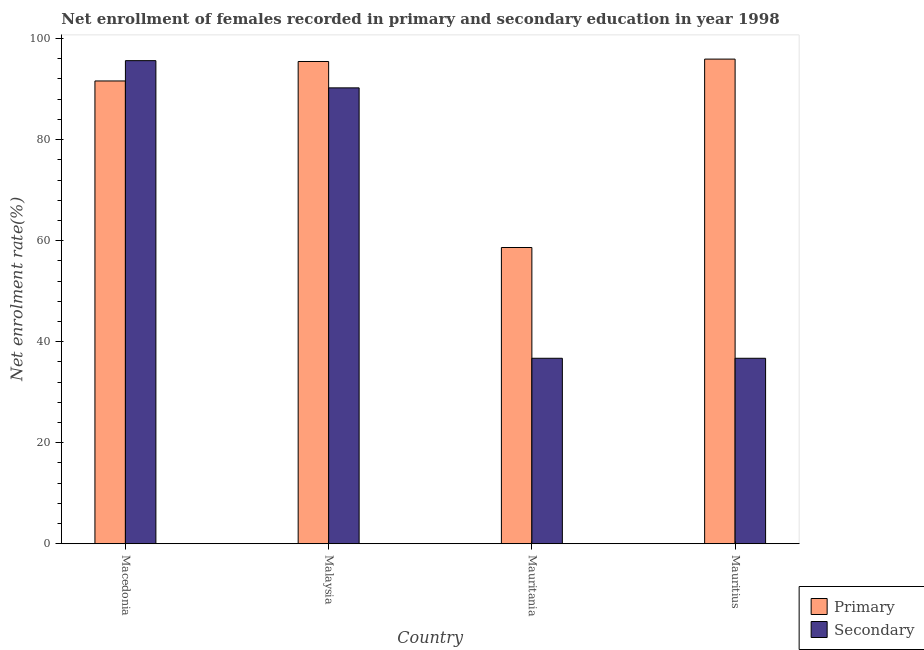Are the number of bars on each tick of the X-axis equal?
Make the answer very short. Yes. How many bars are there on the 3rd tick from the left?
Offer a terse response. 2. What is the label of the 3rd group of bars from the left?
Make the answer very short. Mauritania. In how many cases, is the number of bars for a given country not equal to the number of legend labels?
Ensure brevity in your answer.  0. What is the enrollment rate in secondary education in Malaysia?
Your answer should be very brief. 90.24. Across all countries, what is the maximum enrollment rate in secondary education?
Offer a terse response. 95.63. Across all countries, what is the minimum enrollment rate in primary education?
Offer a very short reply. 58.64. In which country was the enrollment rate in secondary education maximum?
Make the answer very short. Macedonia. In which country was the enrollment rate in secondary education minimum?
Your response must be concise. Mauritania. What is the total enrollment rate in primary education in the graph?
Provide a short and direct response. 341.64. What is the difference between the enrollment rate in primary education in Malaysia and that in Mauritania?
Give a very brief answer. 36.82. What is the difference between the enrollment rate in primary education in Mauritania and the enrollment rate in secondary education in Macedonia?
Make the answer very short. -36.99. What is the average enrollment rate in primary education per country?
Offer a terse response. 85.41. What is the difference between the enrollment rate in secondary education and enrollment rate in primary education in Mauritania?
Make the answer very short. -21.93. What is the ratio of the enrollment rate in secondary education in Macedonia to that in Mauritania?
Offer a very short reply. 2.6. Is the enrollment rate in primary education in Malaysia less than that in Mauritania?
Make the answer very short. No. Is the difference between the enrollment rate in secondary education in Malaysia and Mauritius greater than the difference between the enrollment rate in primary education in Malaysia and Mauritius?
Your answer should be compact. Yes. What is the difference between the highest and the second highest enrollment rate in primary education?
Keep it short and to the point. 0.47. What is the difference between the highest and the lowest enrollment rate in primary education?
Provide a short and direct response. 37.29. Is the sum of the enrollment rate in secondary education in Mauritania and Mauritius greater than the maximum enrollment rate in primary education across all countries?
Offer a terse response. No. What does the 1st bar from the left in Mauritius represents?
Keep it short and to the point. Primary. What does the 1st bar from the right in Malaysia represents?
Provide a short and direct response. Secondary. How many countries are there in the graph?
Ensure brevity in your answer.  4. Are the values on the major ticks of Y-axis written in scientific E-notation?
Your response must be concise. No. How many legend labels are there?
Provide a succinct answer. 2. How are the legend labels stacked?
Ensure brevity in your answer.  Vertical. What is the title of the graph?
Offer a very short reply. Net enrollment of females recorded in primary and secondary education in year 1998. Does "Merchandise exports" appear as one of the legend labels in the graph?
Give a very brief answer. No. What is the label or title of the X-axis?
Your answer should be compact. Country. What is the label or title of the Y-axis?
Your answer should be compact. Net enrolment rate(%). What is the Net enrolment rate(%) in Primary in Macedonia?
Your answer should be compact. 91.61. What is the Net enrolment rate(%) of Secondary in Macedonia?
Offer a very short reply. 95.63. What is the Net enrolment rate(%) in Primary in Malaysia?
Your response must be concise. 95.46. What is the Net enrolment rate(%) in Secondary in Malaysia?
Your answer should be compact. 90.24. What is the Net enrolment rate(%) in Primary in Mauritania?
Your answer should be very brief. 58.64. What is the Net enrolment rate(%) in Secondary in Mauritania?
Provide a succinct answer. 36.71. What is the Net enrolment rate(%) of Primary in Mauritius?
Make the answer very short. 95.93. What is the Net enrolment rate(%) in Secondary in Mauritius?
Keep it short and to the point. 36.71. Across all countries, what is the maximum Net enrolment rate(%) of Primary?
Provide a succinct answer. 95.93. Across all countries, what is the maximum Net enrolment rate(%) of Secondary?
Provide a short and direct response. 95.63. Across all countries, what is the minimum Net enrolment rate(%) of Primary?
Your response must be concise. 58.64. Across all countries, what is the minimum Net enrolment rate(%) of Secondary?
Provide a short and direct response. 36.71. What is the total Net enrolment rate(%) in Primary in the graph?
Offer a terse response. 341.64. What is the total Net enrolment rate(%) of Secondary in the graph?
Provide a short and direct response. 259.29. What is the difference between the Net enrolment rate(%) in Primary in Macedonia and that in Malaysia?
Offer a terse response. -3.85. What is the difference between the Net enrolment rate(%) of Secondary in Macedonia and that in Malaysia?
Provide a short and direct response. 5.39. What is the difference between the Net enrolment rate(%) of Primary in Macedonia and that in Mauritania?
Provide a succinct answer. 32.97. What is the difference between the Net enrolment rate(%) in Secondary in Macedonia and that in Mauritania?
Offer a terse response. 58.91. What is the difference between the Net enrolment rate(%) of Primary in Macedonia and that in Mauritius?
Give a very brief answer. -4.32. What is the difference between the Net enrolment rate(%) in Secondary in Macedonia and that in Mauritius?
Give a very brief answer. 58.91. What is the difference between the Net enrolment rate(%) in Primary in Malaysia and that in Mauritania?
Offer a terse response. 36.82. What is the difference between the Net enrolment rate(%) of Secondary in Malaysia and that in Mauritania?
Provide a succinct answer. 53.53. What is the difference between the Net enrolment rate(%) in Primary in Malaysia and that in Mauritius?
Give a very brief answer. -0.47. What is the difference between the Net enrolment rate(%) in Secondary in Malaysia and that in Mauritius?
Make the answer very short. 53.53. What is the difference between the Net enrolment rate(%) in Primary in Mauritania and that in Mauritius?
Your answer should be very brief. -37.29. What is the difference between the Net enrolment rate(%) in Secondary in Mauritania and that in Mauritius?
Provide a succinct answer. -0. What is the difference between the Net enrolment rate(%) in Primary in Macedonia and the Net enrolment rate(%) in Secondary in Malaysia?
Provide a short and direct response. 1.37. What is the difference between the Net enrolment rate(%) in Primary in Macedonia and the Net enrolment rate(%) in Secondary in Mauritania?
Offer a terse response. 54.9. What is the difference between the Net enrolment rate(%) in Primary in Macedonia and the Net enrolment rate(%) in Secondary in Mauritius?
Keep it short and to the point. 54.89. What is the difference between the Net enrolment rate(%) of Primary in Malaysia and the Net enrolment rate(%) of Secondary in Mauritania?
Ensure brevity in your answer.  58.75. What is the difference between the Net enrolment rate(%) of Primary in Malaysia and the Net enrolment rate(%) of Secondary in Mauritius?
Keep it short and to the point. 58.75. What is the difference between the Net enrolment rate(%) in Primary in Mauritania and the Net enrolment rate(%) in Secondary in Mauritius?
Keep it short and to the point. 21.93. What is the average Net enrolment rate(%) of Primary per country?
Your response must be concise. 85.41. What is the average Net enrolment rate(%) of Secondary per country?
Your answer should be compact. 64.82. What is the difference between the Net enrolment rate(%) in Primary and Net enrolment rate(%) in Secondary in Macedonia?
Provide a short and direct response. -4.02. What is the difference between the Net enrolment rate(%) in Primary and Net enrolment rate(%) in Secondary in Malaysia?
Keep it short and to the point. 5.22. What is the difference between the Net enrolment rate(%) of Primary and Net enrolment rate(%) of Secondary in Mauritania?
Your answer should be very brief. 21.93. What is the difference between the Net enrolment rate(%) in Primary and Net enrolment rate(%) in Secondary in Mauritius?
Offer a very short reply. 59.22. What is the ratio of the Net enrolment rate(%) of Primary in Macedonia to that in Malaysia?
Ensure brevity in your answer.  0.96. What is the ratio of the Net enrolment rate(%) in Secondary in Macedonia to that in Malaysia?
Provide a succinct answer. 1.06. What is the ratio of the Net enrolment rate(%) of Primary in Macedonia to that in Mauritania?
Your answer should be compact. 1.56. What is the ratio of the Net enrolment rate(%) of Secondary in Macedonia to that in Mauritania?
Keep it short and to the point. 2.6. What is the ratio of the Net enrolment rate(%) in Primary in Macedonia to that in Mauritius?
Your response must be concise. 0.95. What is the ratio of the Net enrolment rate(%) in Secondary in Macedonia to that in Mauritius?
Give a very brief answer. 2.6. What is the ratio of the Net enrolment rate(%) of Primary in Malaysia to that in Mauritania?
Provide a short and direct response. 1.63. What is the ratio of the Net enrolment rate(%) in Secondary in Malaysia to that in Mauritania?
Keep it short and to the point. 2.46. What is the ratio of the Net enrolment rate(%) in Secondary in Malaysia to that in Mauritius?
Your response must be concise. 2.46. What is the ratio of the Net enrolment rate(%) of Primary in Mauritania to that in Mauritius?
Ensure brevity in your answer.  0.61. What is the ratio of the Net enrolment rate(%) in Secondary in Mauritania to that in Mauritius?
Ensure brevity in your answer.  1. What is the difference between the highest and the second highest Net enrolment rate(%) in Primary?
Your response must be concise. 0.47. What is the difference between the highest and the second highest Net enrolment rate(%) of Secondary?
Ensure brevity in your answer.  5.39. What is the difference between the highest and the lowest Net enrolment rate(%) of Primary?
Provide a short and direct response. 37.29. What is the difference between the highest and the lowest Net enrolment rate(%) in Secondary?
Your answer should be very brief. 58.91. 